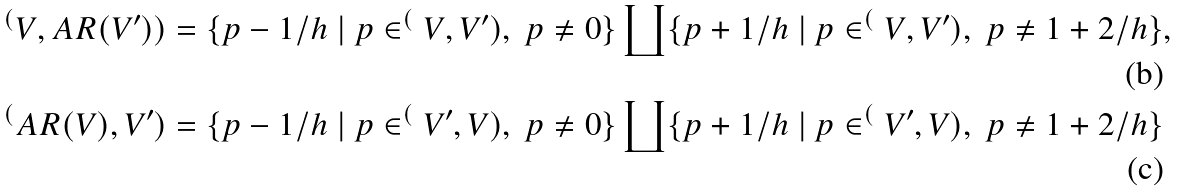<formula> <loc_0><loc_0><loc_500><loc_500>& ^ { ( } V , A R ( V ^ { \prime } ) ) = \{ p - 1 / h \ | \ p \in ^ { ( } V , V ^ { \prime } ) , \ p \ne 0 \} \coprod \{ p + 1 / h \ | \ p \in ^ { ( } V , V ^ { \prime } ) , \ p \ne 1 + 2 / h \} , \\ & ^ { ( } A R ( V ) , V ^ { \prime } ) = \{ p - 1 / h \ | \ p \in ^ { ( } V ^ { \prime } , V ) , \ p \ne 0 \} \coprod \{ p + 1 / h \ | \ p \in ^ { ( } V ^ { \prime } , V ) , \ p \ne 1 + 2 / h \}</formula> 